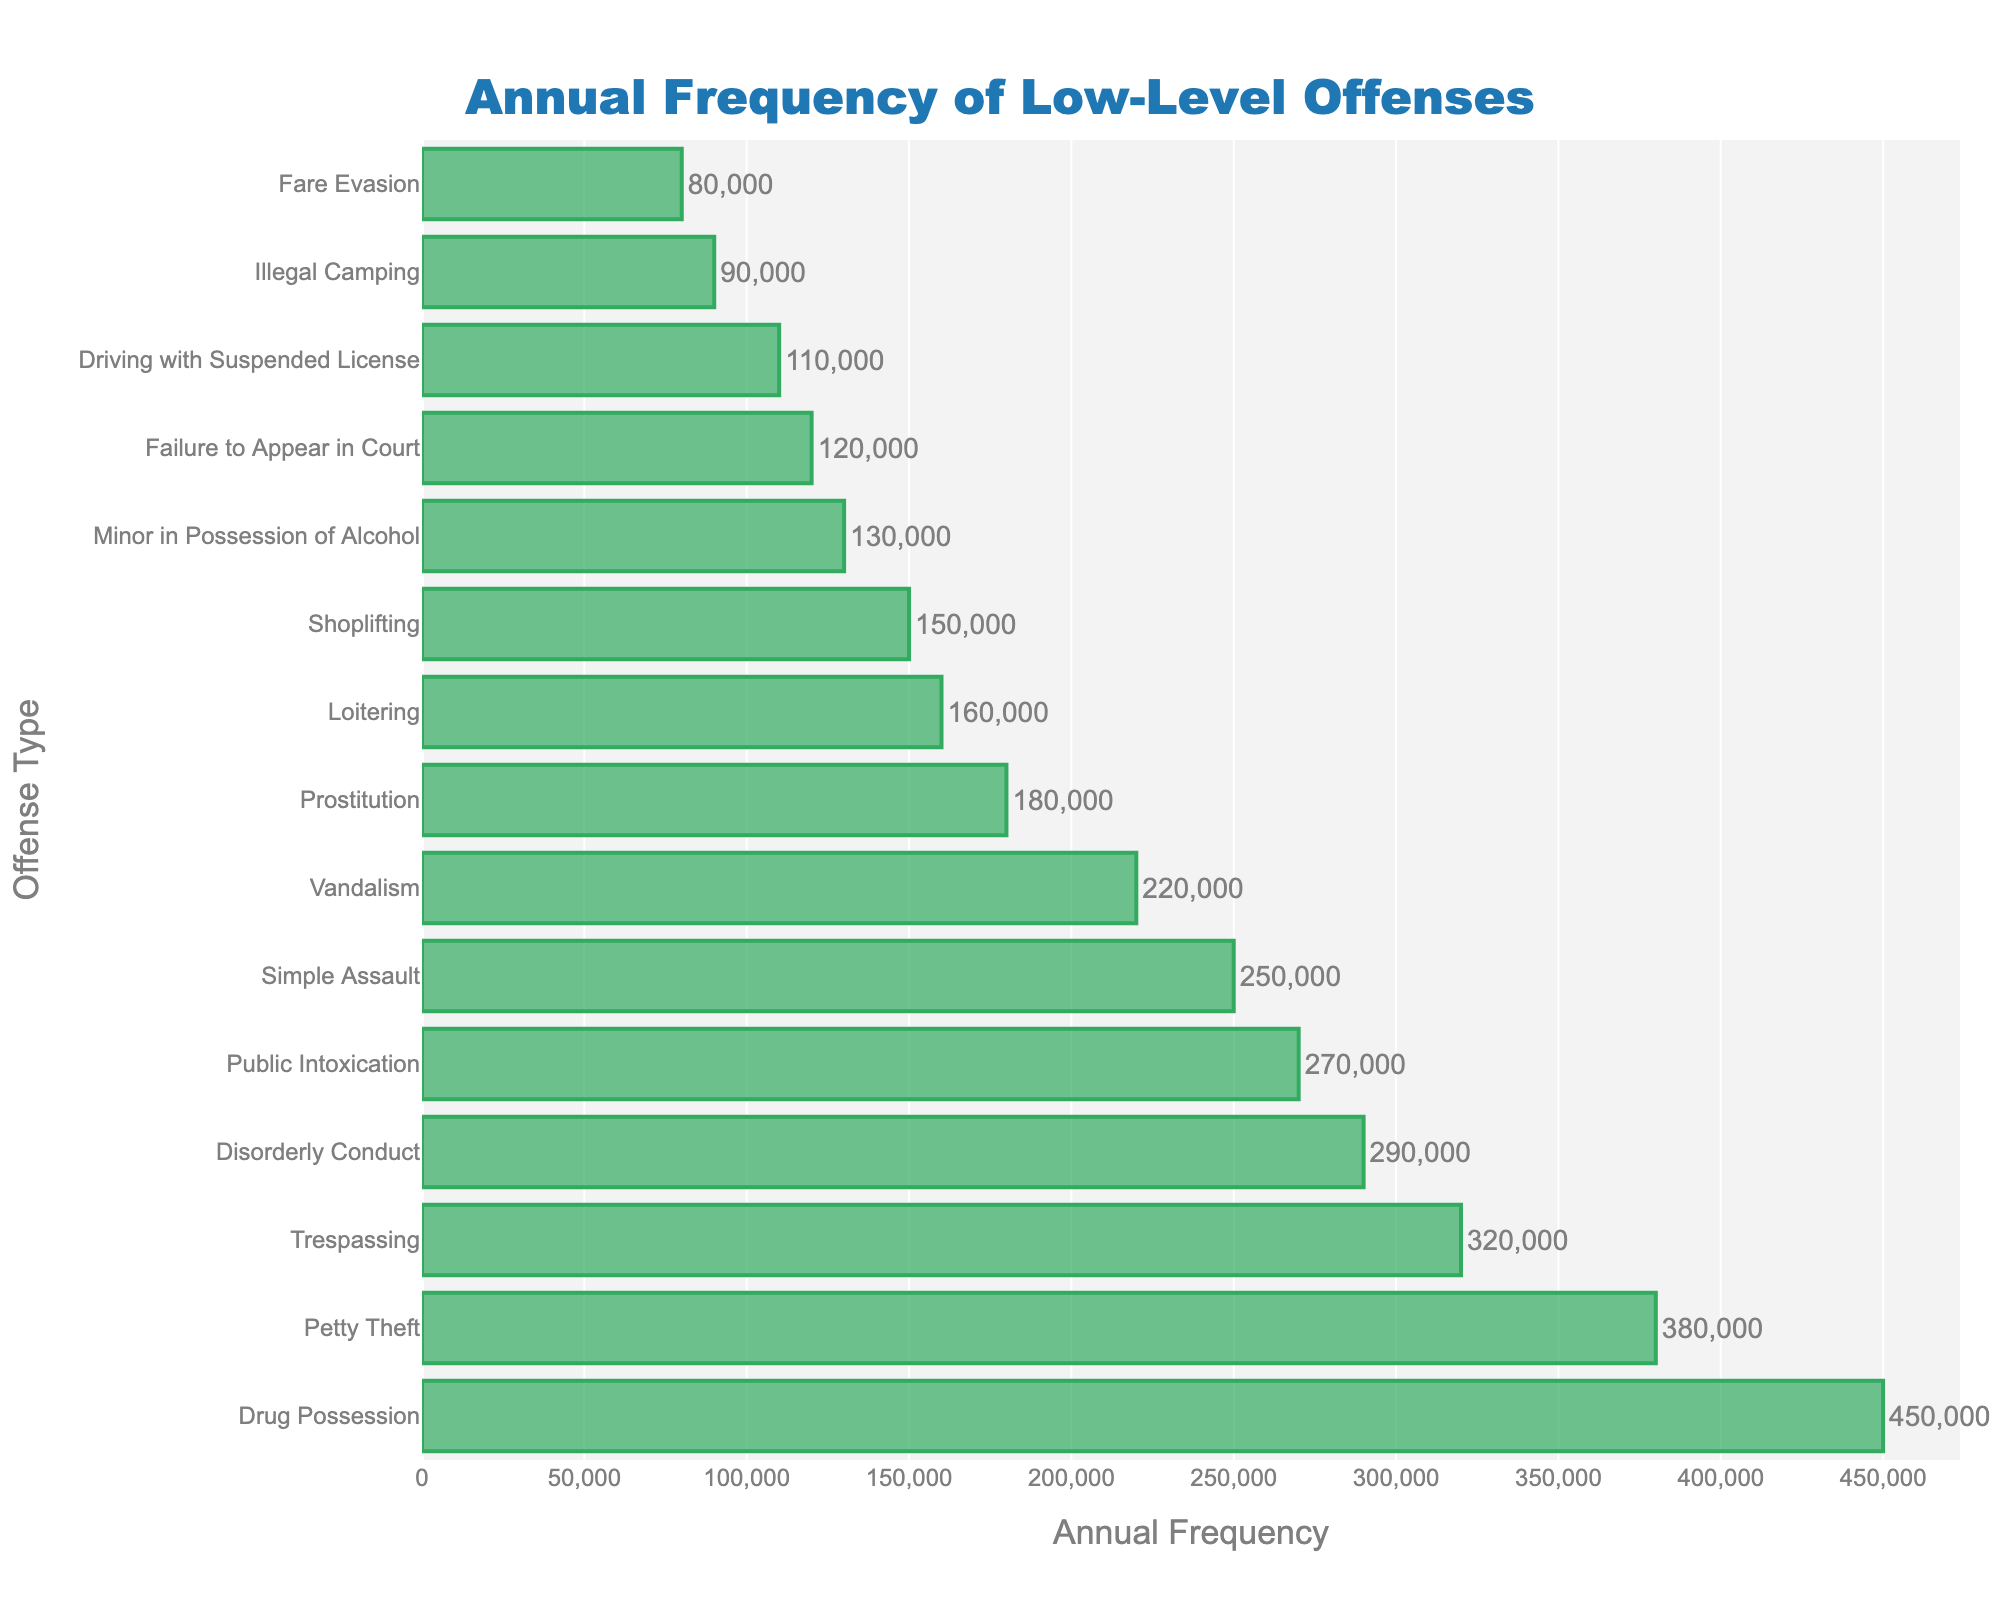What's the most frequent low-level offense? The lengths of the bars represent the frequencies of the offenses. By looking at the longest bar, we can determine the offense with the highest frequency.
Answer: Drug Possession Which offense has a higher frequency: Petty Theft or Vandalism? Compare the lengths of the bars for Petty Theft and Vandalism. The Petty Theft bar is longer than the Vandalism bar.
Answer: Petty Theft What is the total frequency of Petty Theft and Trespassing combined? Find the frequencies of Petty Theft (380,000) and Trespassing (320,000) and add them together: 380,000 + 320,000 = 700,000.
Answer: 700,000 How many offenses have an annual frequency greater than 250,000? Look at the bars and count the number of offenses where the length of the bars indicates a frequency greater than 250,000. This includes Drug Possession, Petty Theft, Trespassing, Disorderly Conduct, Public Intoxication, and Simple Assault.
Answer: 6 Which offense has the lowest frequency, and what is its value? Find the shortest bar on the chart, which represents the offense with the lowest frequency.
Answer: Fare Evasion, 80,000 What is the frequency difference between Simple Assault and Prostitution? Find the frequencies for Simple Assault (250,000) and Prostitution (180,000) and subtract the smaller from the larger: 250,000 - 180,000 = 70,000.
Answer: 70,000 Which offense frequency is closest to the median of all offense frequencies? To find the median, we first order all frequencies and find the middle value. Ordered frequencies are [80,000, 90,000, 110,000, 120,000, 130,000, 150,000, 160,000, 180,000, 220,000, 250,000, 270,000, 290,000, 320,000, 380,000, 450,000]. The median value is the 8th value, which is 180,000. Comparatively, the frequency closest to 180,000 is Prostitution.
Answer: Prostitution Is the frequency of Trespassing higher or lower than that of Disorderly Conduct? Compare the lengths of the bars for Trespassing and Disorderly Conduct. The Trespassing bar is longer indicating it has a higher frequency.
Answer: Higher What is the combined frequency of offenses related to alcohol (Public Intoxication and Minor in Possession of Alcohol)? Find the frequencies for Public Intoxication (270,000) and Minor in Possession of Alcohol (130,000) and add them together: 270,000 + 130,000 = 400,000.
Answer: 400,000 How much more frequent is Drug Possession compared to Shoplifting? Find the frequencies for Drug Possession (450,000) and Shoplifting (150,000) and subtract the smaller from the larger: 450,000 - 150,000 = 300,000.
Answer: 300,000 